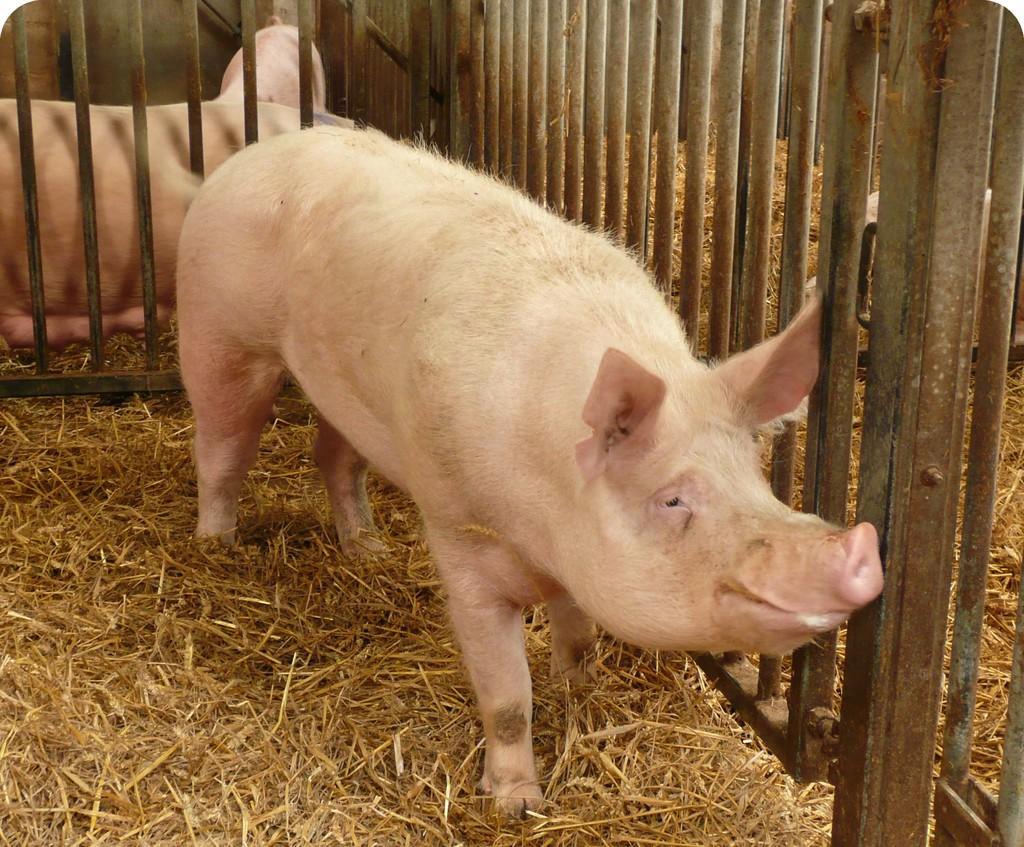Can you describe this image briefly? In this picture we can see pigs on the ground, here we can see a fence and dried grass. 